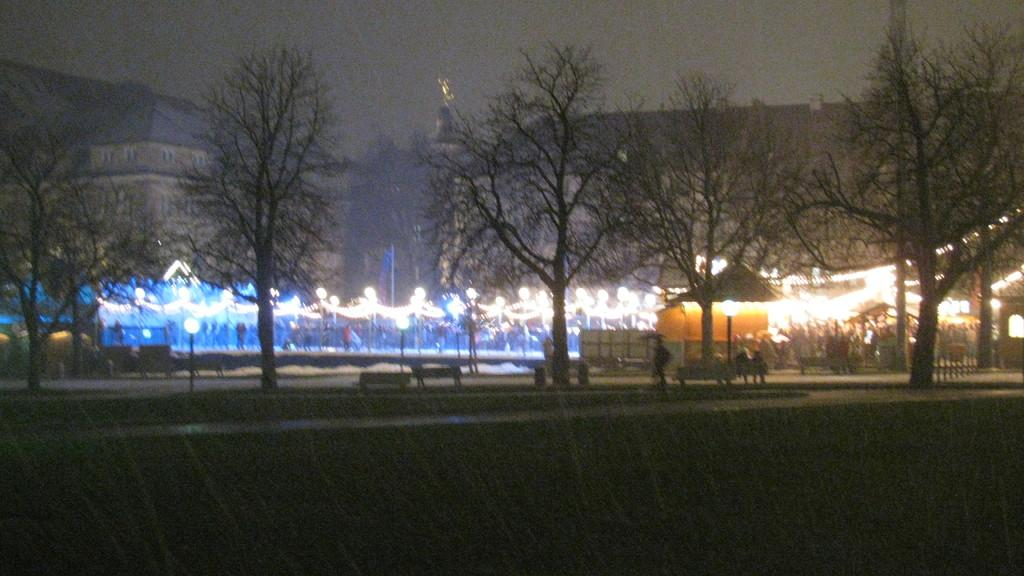What is located in the center of the image? There are trees, lights, tents, a railing, benches, buildings, and people in the center of the image. Can you describe the lighting in the image? There are lights in the center of the image. What type of structures can be seen in the image? There are tents and buildings in the center of the image. What is the condition of the sky in the image? The sky is dark in the image. How many different elements are present in the center of the image? There are at least eight different elements present in the center of the image. What type of goose is being used to prepare tea in the image? There is no goose or kettle present in the image, and therefore no such activity can be observed. What type of apparel is being worn by the people in the image? The image does not provide enough detail to determine the type of apparel being worn by the people. 